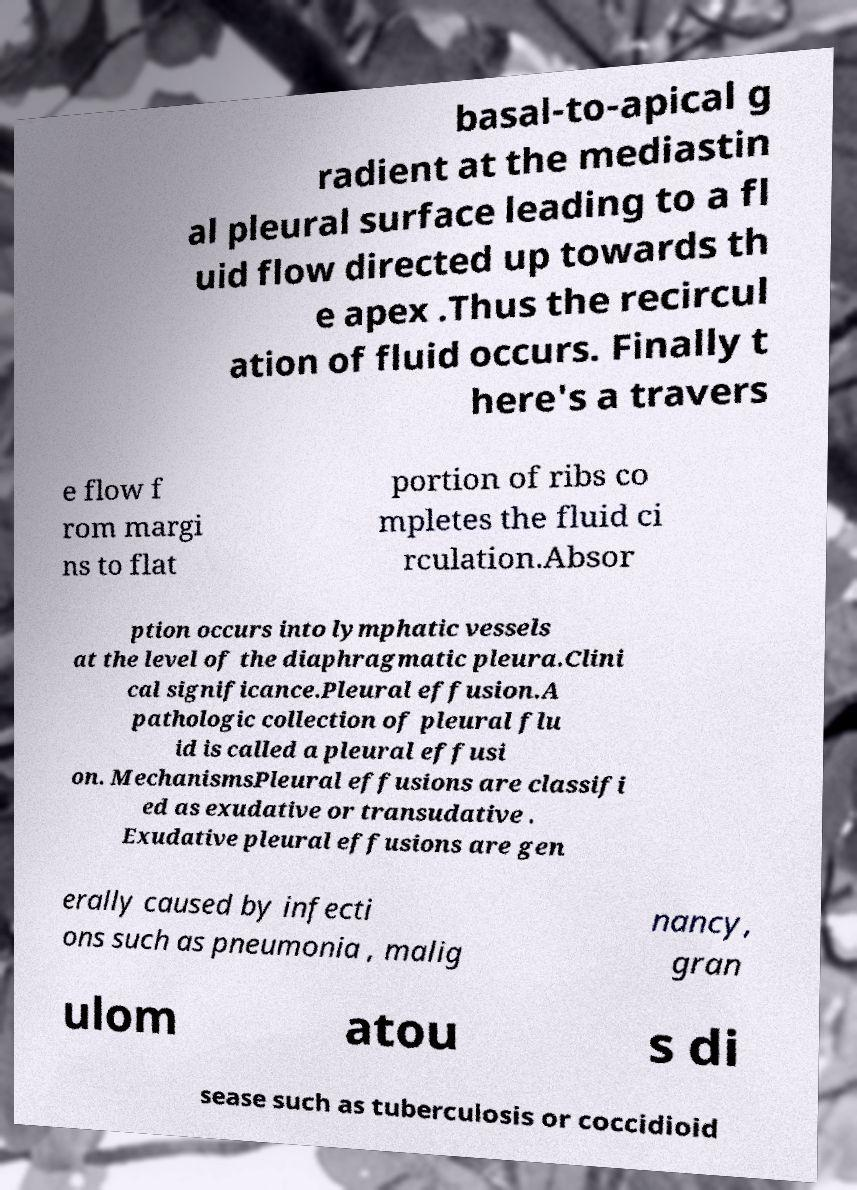Could you extract and type out the text from this image? basal-to-apical g radient at the mediastin al pleural surface leading to a fl uid flow directed up towards th e apex .Thus the recircul ation of fluid occurs. Finally t here's a travers e flow f rom margi ns to flat portion of ribs co mpletes the fluid ci rculation.Absor ption occurs into lymphatic vessels at the level of the diaphragmatic pleura.Clini cal significance.Pleural effusion.A pathologic collection of pleural flu id is called a pleural effusi on. MechanismsPleural effusions are classifi ed as exudative or transudative . Exudative pleural effusions are gen erally caused by infecti ons such as pneumonia , malig nancy, gran ulom atou s di sease such as tuberculosis or coccidioid 